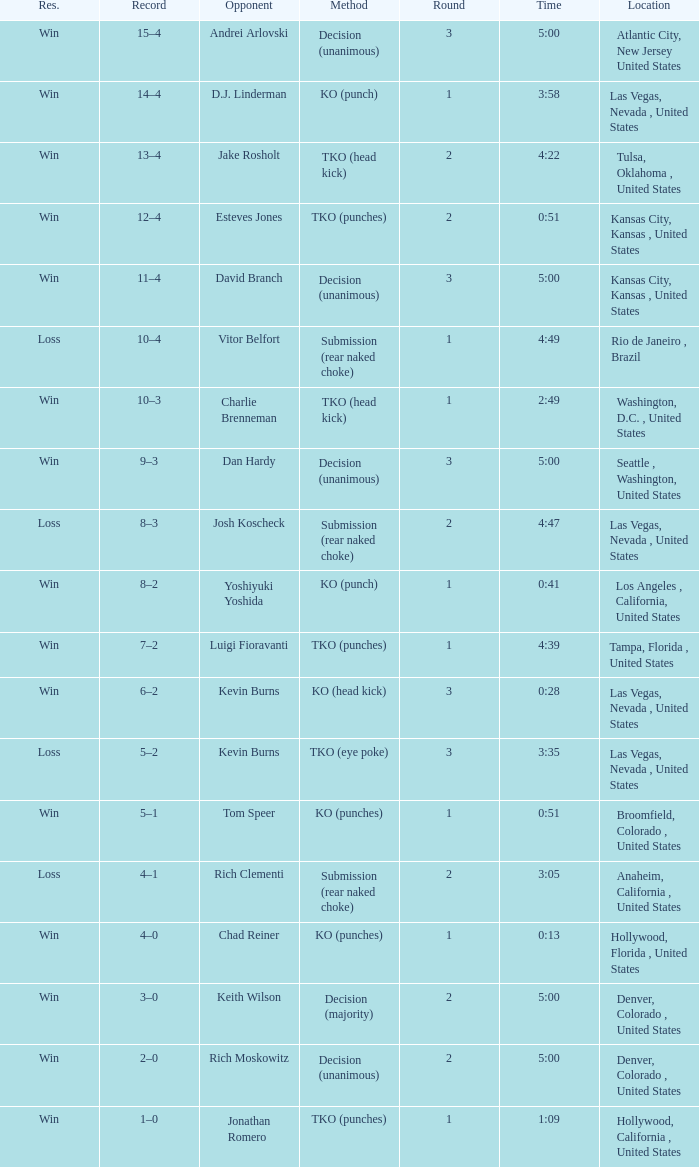What is the highest round number with a time of 4:39? 1.0. 